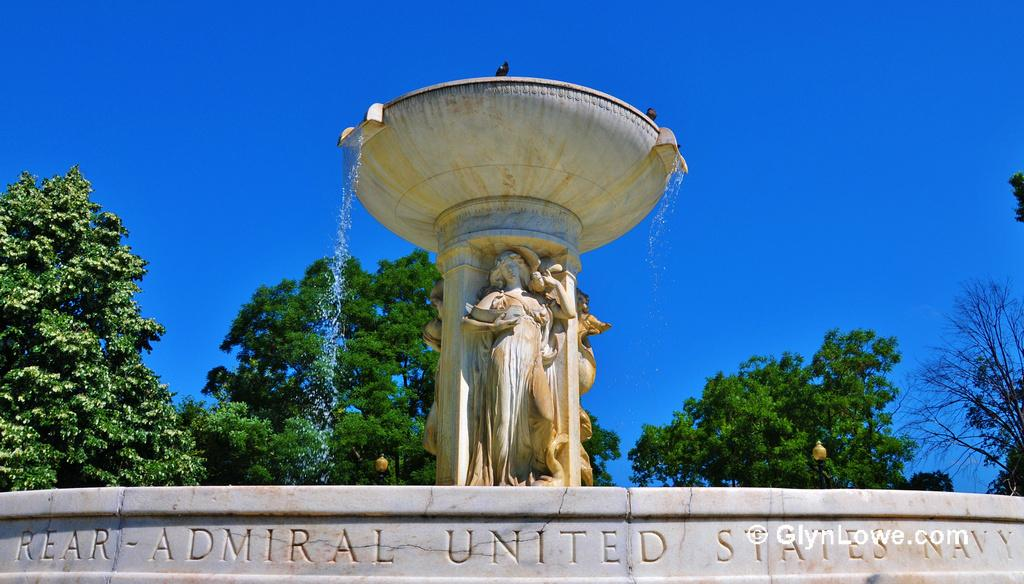What is the main subject in the image? There is a statue in the image. Can you describe the statue's appearance? The statue is in cream color. What other feature is present in the image besides the statue? There is a fountain in the image. What can be seen in the background of the image? There are trees in the background of the image, and they are green. What is the color of the sky in the image? The sky is blue in the image. What is the income of the person who created the statue in the image? There is no information about the income of the person who created the statue in the image. How many cans are visible in the image? There are no cans present in the image. 